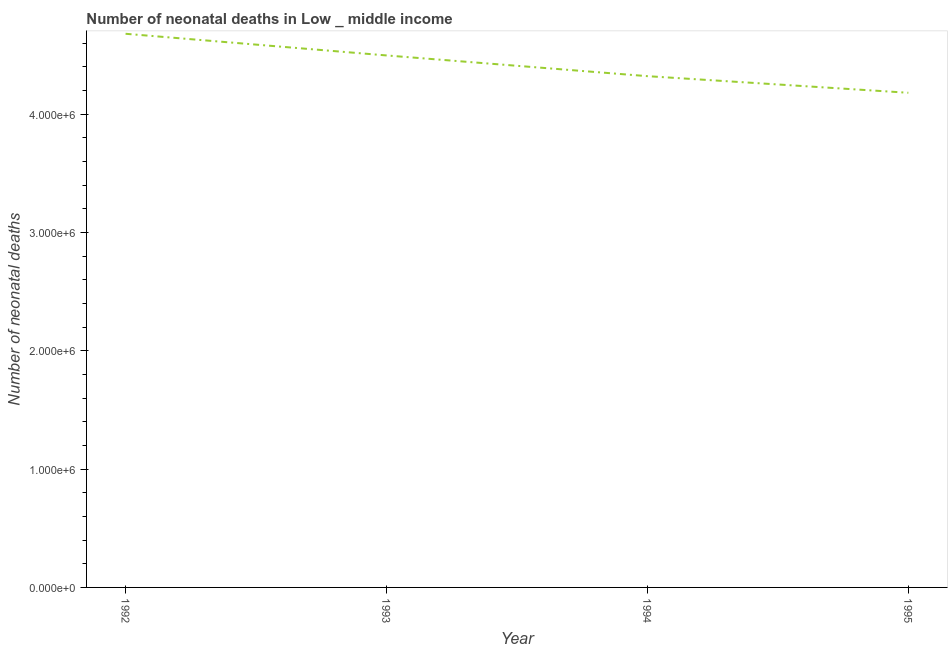What is the number of neonatal deaths in 1994?
Offer a very short reply. 4.32e+06. Across all years, what is the maximum number of neonatal deaths?
Make the answer very short. 4.68e+06. Across all years, what is the minimum number of neonatal deaths?
Your response must be concise. 4.18e+06. In which year was the number of neonatal deaths maximum?
Your answer should be compact. 1992. In which year was the number of neonatal deaths minimum?
Provide a succinct answer. 1995. What is the sum of the number of neonatal deaths?
Offer a terse response. 1.77e+07. What is the difference between the number of neonatal deaths in 1993 and 1994?
Make the answer very short. 1.75e+05. What is the average number of neonatal deaths per year?
Make the answer very short. 4.42e+06. What is the median number of neonatal deaths?
Offer a terse response. 4.41e+06. In how many years, is the number of neonatal deaths greater than 1600000 ?
Your answer should be compact. 4. What is the ratio of the number of neonatal deaths in 1992 to that in 1995?
Provide a succinct answer. 1.12. What is the difference between the highest and the second highest number of neonatal deaths?
Give a very brief answer. 1.83e+05. Is the sum of the number of neonatal deaths in 1992 and 1994 greater than the maximum number of neonatal deaths across all years?
Provide a short and direct response. Yes. What is the difference between the highest and the lowest number of neonatal deaths?
Offer a very short reply. 4.99e+05. In how many years, is the number of neonatal deaths greater than the average number of neonatal deaths taken over all years?
Provide a succinct answer. 2. How many lines are there?
Your answer should be very brief. 1. How many years are there in the graph?
Ensure brevity in your answer.  4. Does the graph contain any zero values?
Provide a succinct answer. No. Does the graph contain grids?
Make the answer very short. No. What is the title of the graph?
Ensure brevity in your answer.  Number of neonatal deaths in Low _ middle income. What is the label or title of the Y-axis?
Make the answer very short. Number of neonatal deaths. What is the Number of neonatal deaths of 1992?
Keep it short and to the point. 4.68e+06. What is the Number of neonatal deaths of 1993?
Your answer should be compact. 4.50e+06. What is the Number of neonatal deaths of 1994?
Offer a very short reply. 4.32e+06. What is the Number of neonatal deaths of 1995?
Offer a very short reply. 4.18e+06. What is the difference between the Number of neonatal deaths in 1992 and 1993?
Provide a succinct answer. 1.83e+05. What is the difference between the Number of neonatal deaths in 1992 and 1994?
Make the answer very short. 3.58e+05. What is the difference between the Number of neonatal deaths in 1992 and 1995?
Provide a short and direct response. 4.99e+05. What is the difference between the Number of neonatal deaths in 1993 and 1994?
Your answer should be compact. 1.75e+05. What is the difference between the Number of neonatal deaths in 1993 and 1995?
Keep it short and to the point. 3.16e+05. What is the difference between the Number of neonatal deaths in 1994 and 1995?
Make the answer very short. 1.40e+05. What is the ratio of the Number of neonatal deaths in 1992 to that in 1993?
Your response must be concise. 1.04. What is the ratio of the Number of neonatal deaths in 1992 to that in 1994?
Offer a terse response. 1.08. What is the ratio of the Number of neonatal deaths in 1992 to that in 1995?
Offer a very short reply. 1.12. What is the ratio of the Number of neonatal deaths in 1993 to that in 1994?
Keep it short and to the point. 1.04. What is the ratio of the Number of neonatal deaths in 1993 to that in 1995?
Offer a terse response. 1.07. What is the ratio of the Number of neonatal deaths in 1994 to that in 1995?
Provide a short and direct response. 1.03. 